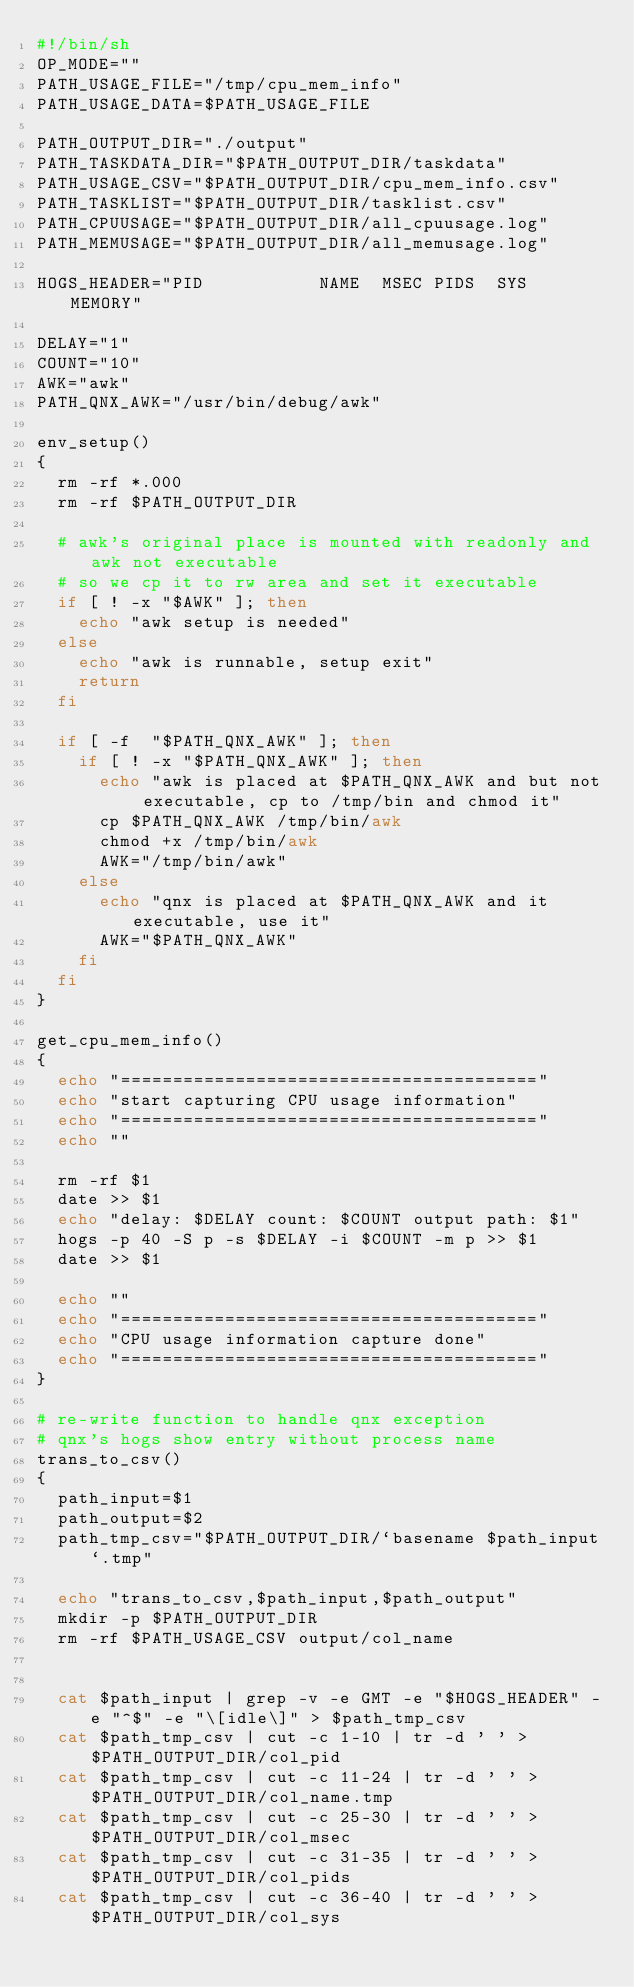Convert code to text. <code><loc_0><loc_0><loc_500><loc_500><_Bash_>#!/bin/sh
OP_MODE=""
PATH_USAGE_FILE="/tmp/cpu_mem_info"
PATH_USAGE_DATA=$PATH_USAGE_FILE

PATH_OUTPUT_DIR="./output"
PATH_TASKDATA_DIR="$PATH_OUTPUT_DIR/taskdata"
PATH_USAGE_CSV="$PATH_OUTPUT_DIR/cpu_mem_info.csv"
PATH_TASKLIST="$PATH_OUTPUT_DIR/tasklist.csv"
PATH_CPUUSAGE="$PATH_OUTPUT_DIR/all_cpuusage.log"
PATH_MEMUSAGE="$PATH_OUTPUT_DIR/all_memusage.log"

HOGS_HEADER="PID           NAME  MSEC PIDS  SYS       MEMORY"

DELAY="1"
COUNT="10"
AWK="awk"
PATH_QNX_AWK="/usr/bin/debug/awk"

env_setup()
{
	rm -rf *.000
	rm -rf $PATH_OUTPUT_DIR

	# awk's original place is mounted with readonly and awk not executable
	# so we cp it to rw area and set it executable
	if [ ! -x "$AWK" ]; then
		echo "awk setup is needed"
	else
		echo "awk is runnable, setup exit"
		return
	fi

	if [ -f  "$PATH_QNX_AWK" ]; then
		if [ ! -x "$PATH_QNX_AWK" ]; then
			echo "awk is placed at $PATH_QNX_AWK and but not executable, cp to /tmp/bin and chmod it"
			cp $PATH_QNX_AWK /tmp/bin/awk
			chmod +x /tmp/bin/awk
			AWK="/tmp/bin/awk"
		else
			echo "qnx is placed at $PATH_QNX_AWK and it executable, use it"
			AWK="$PATH_QNX_AWK"
		fi
	fi
}

get_cpu_mem_info()
{
	echo "========================================"
	echo "start capturing CPU usage information"
	echo "========================================"
	echo ""

	rm -rf $1
	date >> $1
	echo "delay: $DELAY count: $COUNT output path: $1"
	hogs -p 40 -S p -s $DELAY -i $COUNT -m p >> $1
	date >> $1

	echo ""
	echo "========================================"
	echo "CPU usage information capture done"
	echo "========================================"
}

# re-write function to handle qnx exception
# qnx's hogs show entry without process name
trans_to_csv()
{
	path_input=$1
	path_output=$2
	path_tmp_csv="$PATH_OUTPUT_DIR/`basename $path_input`.tmp"

	echo "trans_to_csv,$path_input,$path_output"
	mkdir -p $PATH_OUTPUT_DIR
	rm -rf $PATH_USAGE_CSV output/col_name


	cat $path_input | grep -v -e GMT -e "$HOGS_HEADER" -e "^$" -e "\[idle\]" > $path_tmp_csv
	cat $path_tmp_csv | cut -c 1-10 | tr -d ' ' > $PATH_OUTPUT_DIR/col_pid
	cat $path_tmp_csv | cut -c 11-24 | tr -d ' ' > $PATH_OUTPUT_DIR/col_name.tmp
	cat $path_tmp_csv | cut -c 25-30 | tr -d ' ' > $PATH_OUTPUT_DIR/col_msec
	cat $path_tmp_csv | cut -c 31-35 | tr -d ' ' > $PATH_OUTPUT_DIR/col_pids
	cat $path_tmp_csv | cut -c 36-40 | tr -d ' ' > $PATH_OUTPUT_DIR/col_sys</code> 